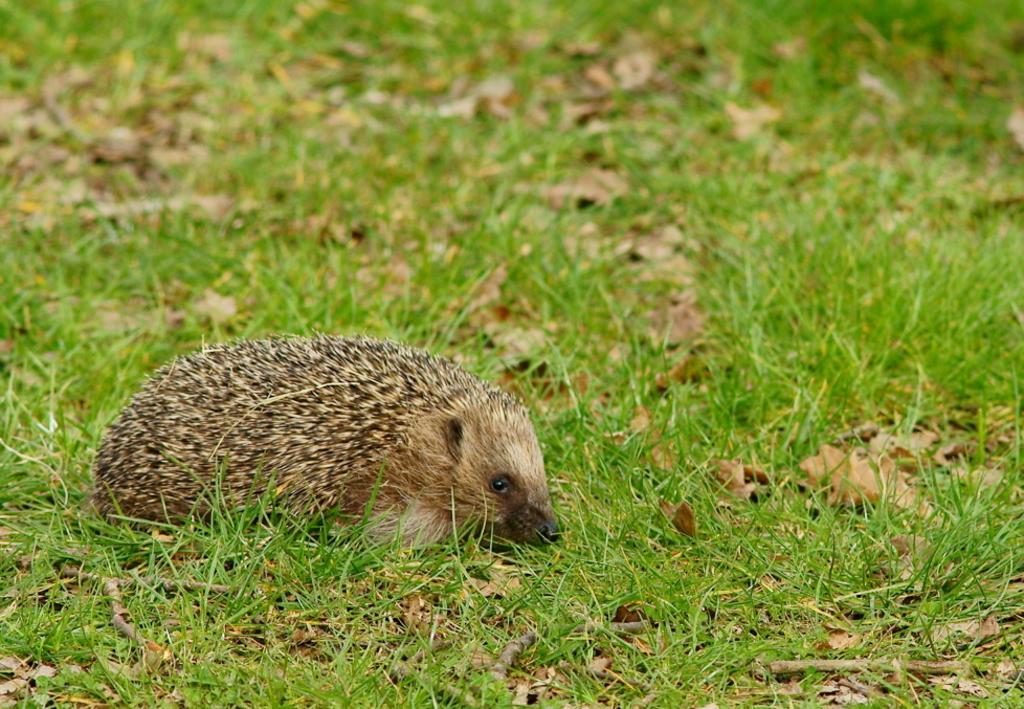In one or two sentences, can you explain what this image depicts? This picture shows a Porcupine and we see grass on the ground. It is brown in color. 